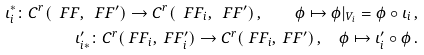<formula> <loc_0><loc_0><loc_500><loc_500>\iota _ { i } ^ { * } \colon C ^ { r } ( \ F F , \ F F ^ { \prime } ) \to C ^ { r } ( \ F F _ { i } , \ F F ^ { \prime } ) \, , \quad \phi \mapsto \phi | _ { V _ { i } } = \phi \circ \iota _ { i } \, , \\ \iota ^ { \prime } _ { i * } \colon C ^ { r } ( \ F F _ { i } , \ F F ^ { \prime } _ { i } ) \to C ^ { r } ( \ F F _ { i } , \ F F ^ { \prime } ) \, , \quad \phi \mapsto \iota ^ { \prime } _ { i } \circ \phi \, .</formula> 